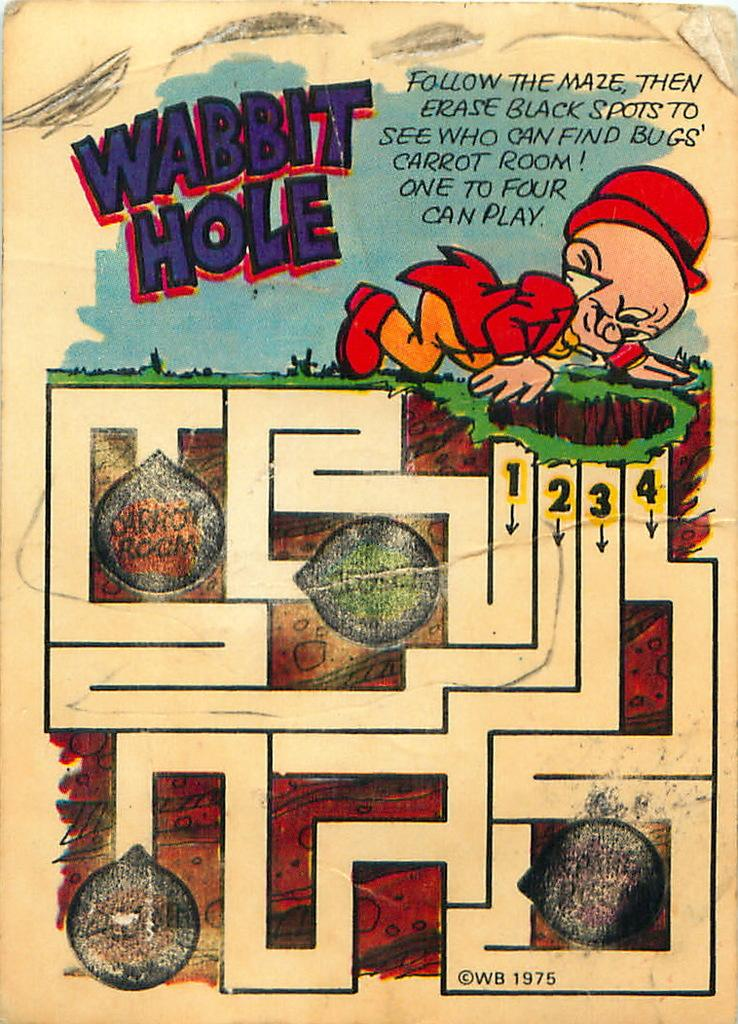Provide a one-sentence caption for the provided image. Elmer fudd looking for the carrot room, this is a maze. 